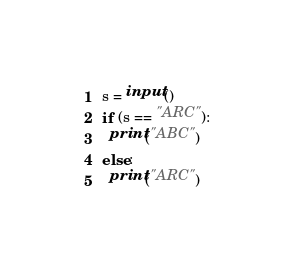<code> <loc_0><loc_0><loc_500><loc_500><_Python_>s = input()
if (s == "ARC"):
  print("ABC")
else:
  print("ARC")</code> 